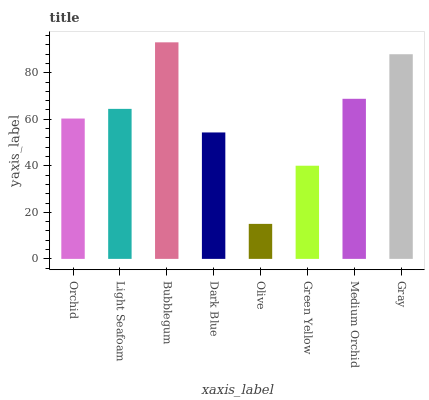Is Olive the minimum?
Answer yes or no. Yes. Is Bubblegum the maximum?
Answer yes or no. Yes. Is Light Seafoam the minimum?
Answer yes or no. No. Is Light Seafoam the maximum?
Answer yes or no. No. Is Light Seafoam greater than Orchid?
Answer yes or no. Yes. Is Orchid less than Light Seafoam?
Answer yes or no. Yes. Is Orchid greater than Light Seafoam?
Answer yes or no. No. Is Light Seafoam less than Orchid?
Answer yes or no. No. Is Light Seafoam the high median?
Answer yes or no. Yes. Is Orchid the low median?
Answer yes or no. Yes. Is Medium Orchid the high median?
Answer yes or no. No. Is Light Seafoam the low median?
Answer yes or no. No. 